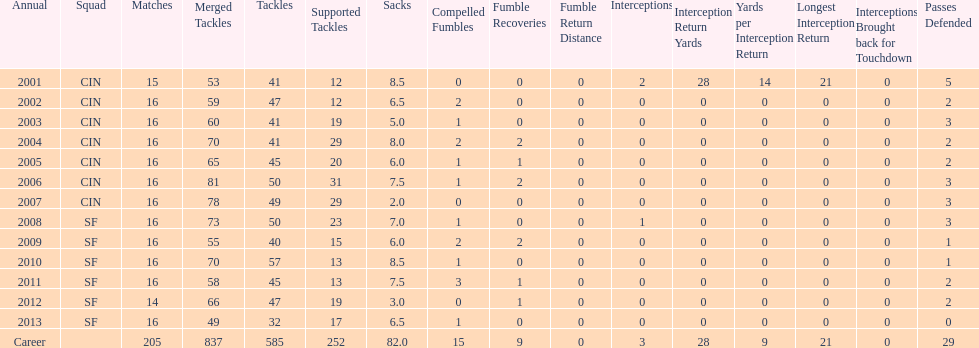How many seasons had combined tackles of 70 or more? 5. 